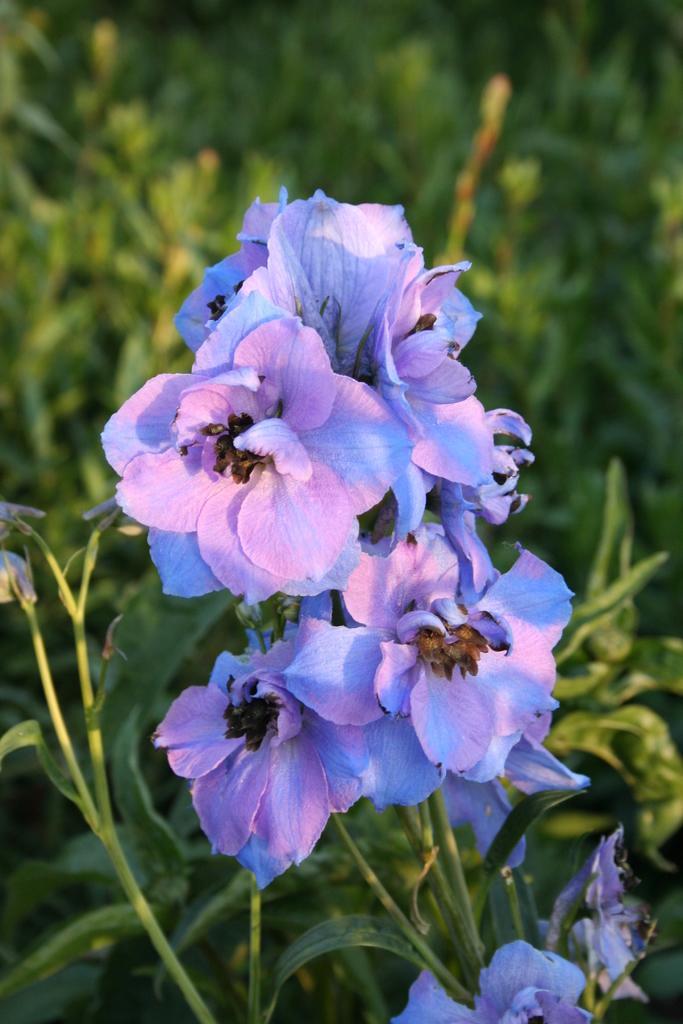How would you summarize this image in a sentence or two? As we can see in the image there are plants and flowers. The background is blurred. 